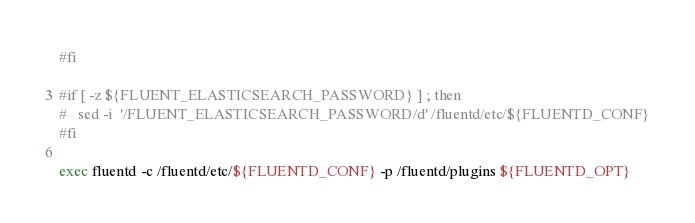<code> <loc_0><loc_0><loc_500><loc_500><_Bash_>#fi

#if [ -z ${FLUENT_ELASTICSEARCH_PASSWORD} ] ; then
#   sed -i  '/FLUENT_ELASTICSEARCH_PASSWORD/d' /fluentd/etc/${FLUENTD_CONF}
#fi

exec fluentd -c /fluentd/etc/${FLUENTD_CONF} -p /fluentd/plugins ${FLUENTD_OPT}
</code> 